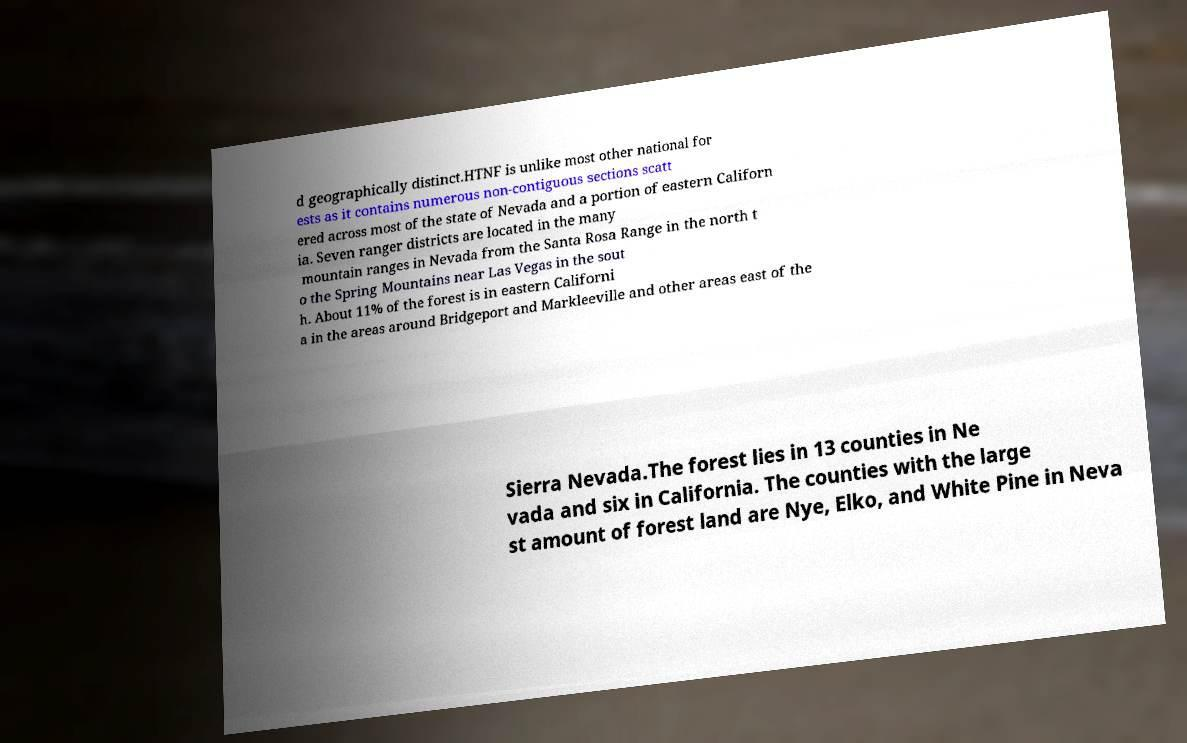For documentation purposes, I need the text within this image transcribed. Could you provide that? d geographically distinct.HTNF is unlike most other national for ests as it contains numerous non-contiguous sections scatt ered across most of the state of Nevada and a portion of eastern Californ ia. Seven ranger districts are located in the many mountain ranges in Nevada from the Santa Rosa Range in the north t o the Spring Mountains near Las Vegas in the sout h. About 11% of the forest is in eastern Californi a in the areas around Bridgeport and Markleeville and other areas east of the Sierra Nevada.The forest lies in 13 counties in Ne vada and six in California. The counties with the large st amount of forest land are Nye, Elko, and White Pine in Neva 